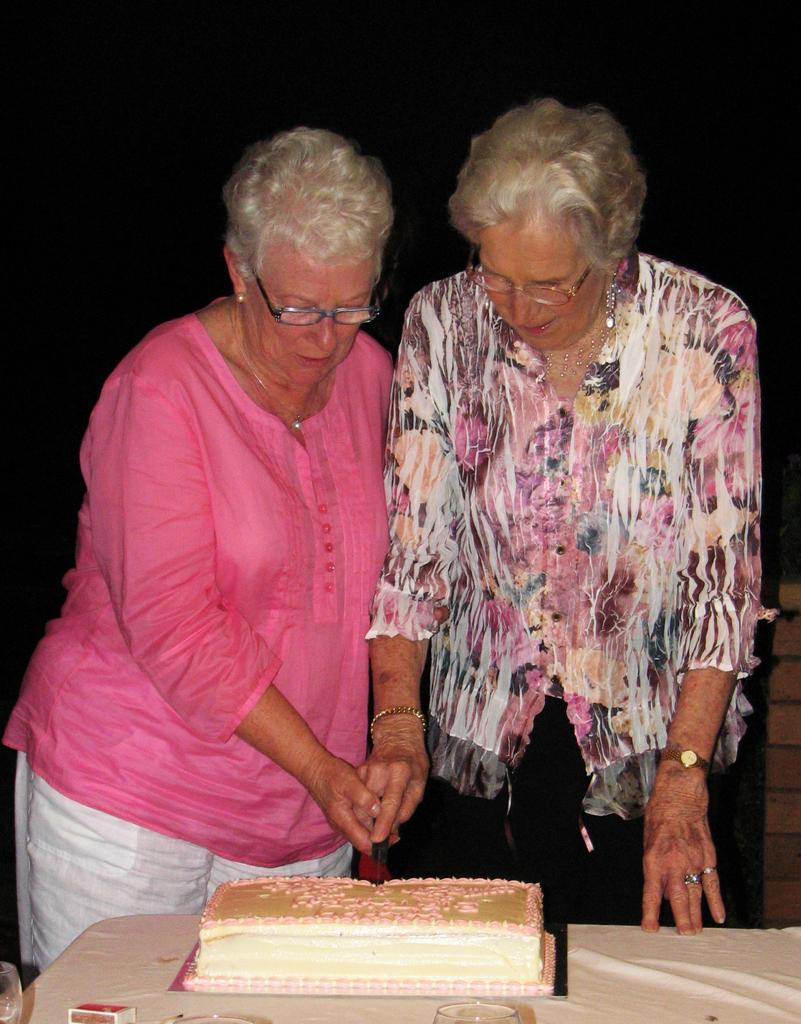How would you summarize this image in a sentence or two? In this picture we can see two persons standing together and cutting the cake. This is the table and there is a matchbox on the table. Here we can see these two persons wearing spectacles. 